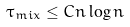<formula> <loc_0><loc_0><loc_500><loc_500>\tau _ { m i x } \leq C n \log n</formula> 